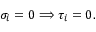<formula> <loc_0><loc_0><loc_500><loc_500>\sigma _ { i } = 0 \Longrightarrow \tau _ { i } = 0 .</formula> 